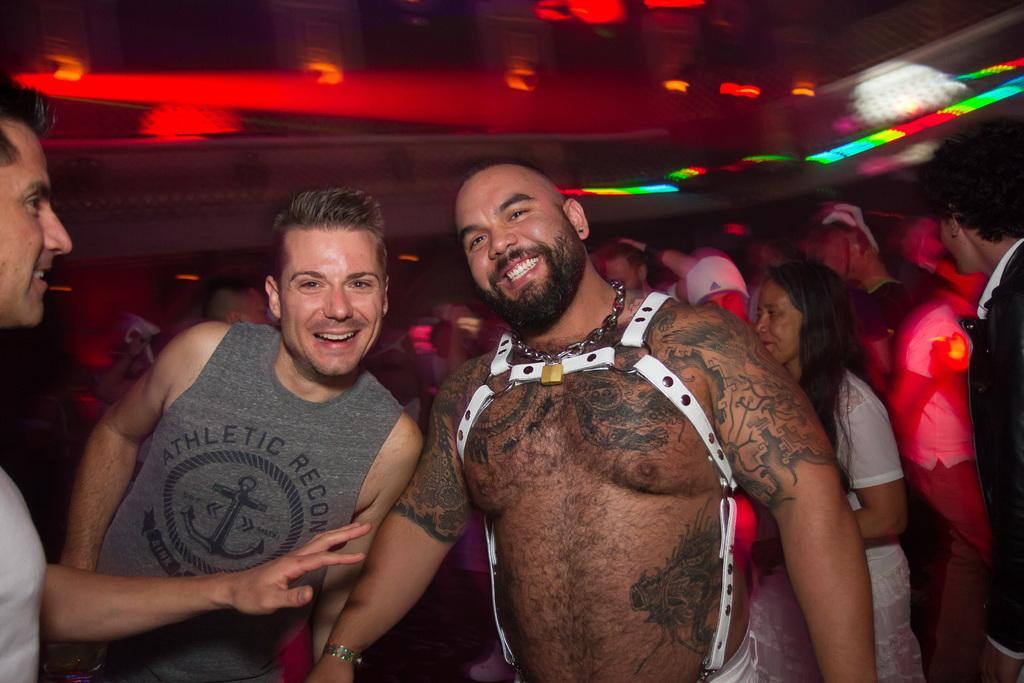How would you summarize this image in a sentence or two? In this image we can see three people standing and smiling. In the background there is crowd. At the top there are lights. 